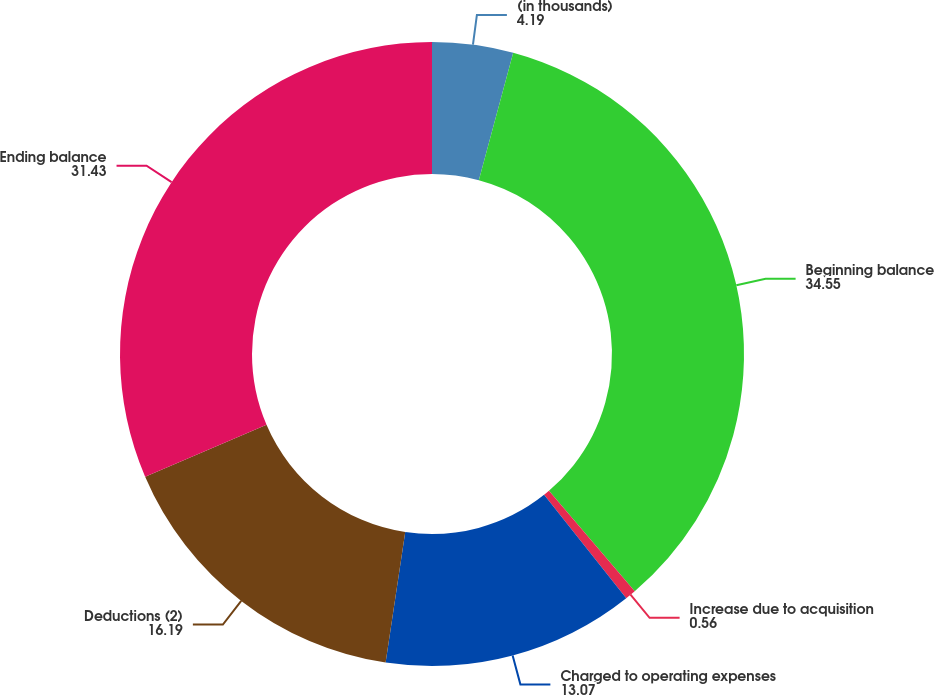<chart> <loc_0><loc_0><loc_500><loc_500><pie_chart><fcel>(in thousands)<fcel>Beginning balance<fcel>Increase due to acquisition<fcel>Charged to operating expenses<fcel>Deductions (2)<fcel>Ending balance<nl><fcel>4.19%<fcel>34.55%<fcel>0.56%<fcel>13.07%<fcel>16.19%<fcel>31.43%<nl></chart> 